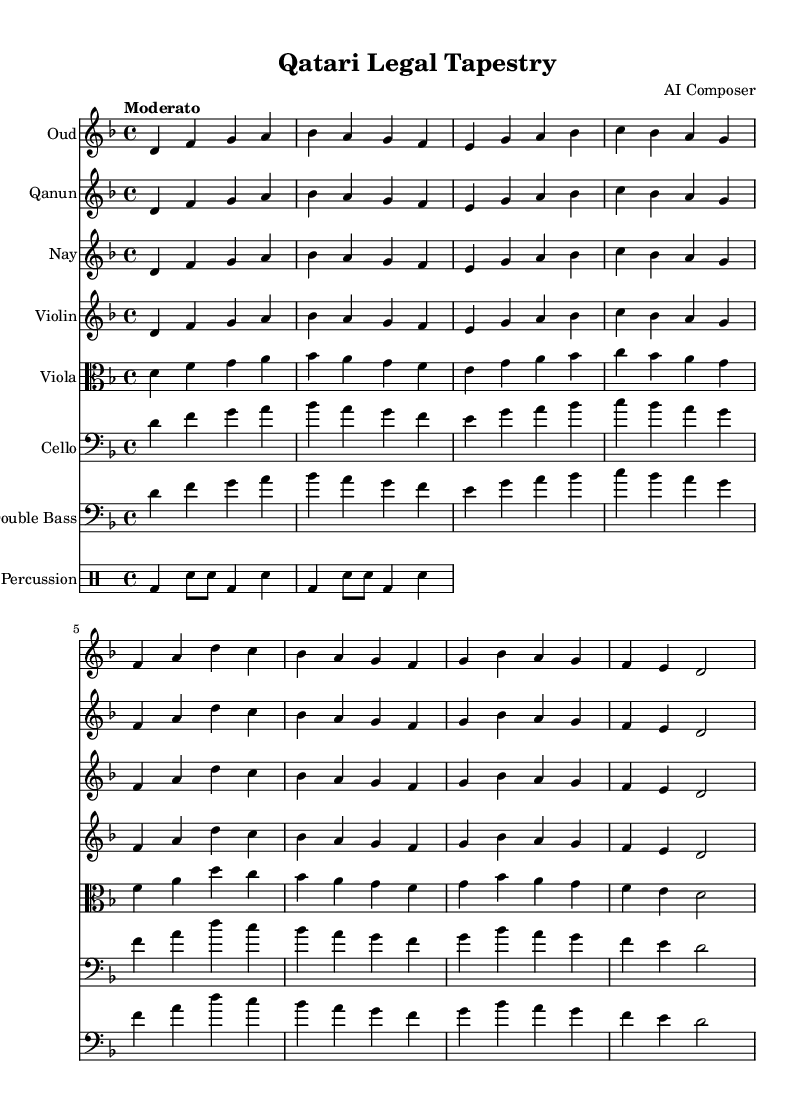What is the key signature of this music? The key signature indicated in the sheet music is D minor, which has one flat (B flat).
Answer: D minor What is the time signature of this music? The time signature shown in the sheet music is 4/4, meaning there are four beats in each measure.
Answer: 4/4 What is the tempo marking for this piece? The tempo marking stated in the music is "Moderato," which implies a moderate pace.
Answer: Moderato How many instruments are present in the orchestration? The sheet music includes a total of seven instrumental staves, indicating seven different instruments: Oud, Qanun, Nay, Violin, Viola, Cello, Double Bass, and a Percussion staff.
Answer: Seven What are the main instruments used in this orchestral piece? The primary instruments featured are traditional Middle Eastern instruments such as Oud, Qanun, and Nay, alongside Western classical instruments like Violin, Viola, Cello, and Double Bass.
Answer: Oud, Qanun, Nay, Violin, Viola, Cello, Double Bass What is the rhythmic pattern used in the percussion? The percussion section follows a straightforward two-beat pattern of bass drum and snare notes, which repeats every two measures, creating a steady rhythmic foundation.
Answer: Bass drum, snare 